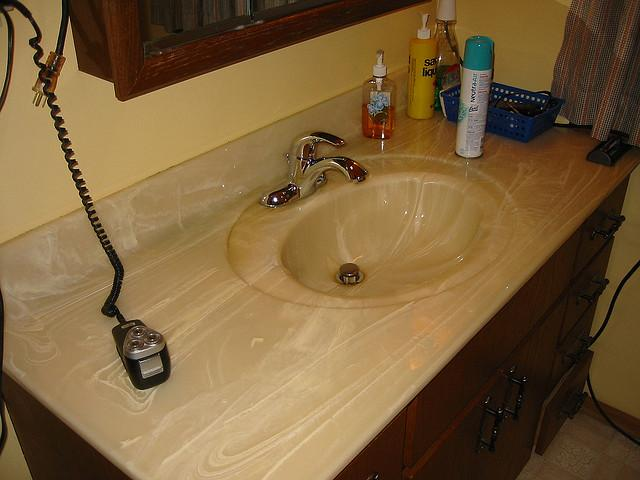What is the corded object called? razor 